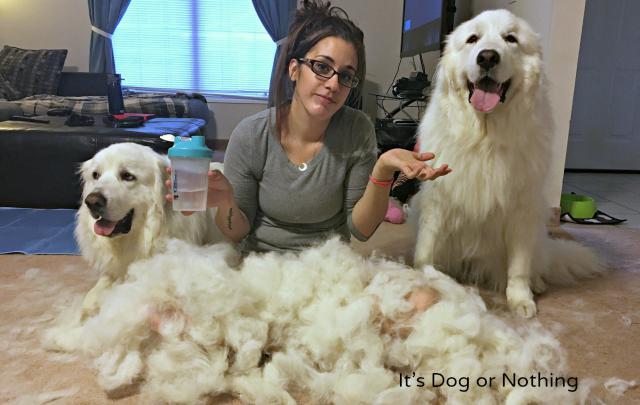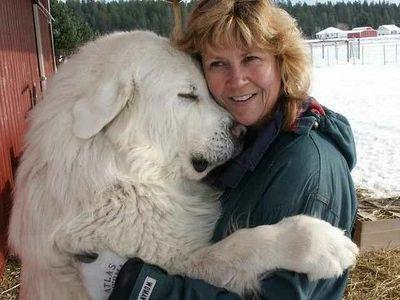The first image is the image on the left, the second image is the image on the right. Given the left and right images, does the statement "There are piles of fur on the floor in at least one picture." hold true? Answer yes or no. Yes. The first image is the image on the left, the second image is the image on the right. Given the left and right images, does the statement "Atleast one dog is sitting next to a pile of hair." hold true? Answer yes or no. Yes. 